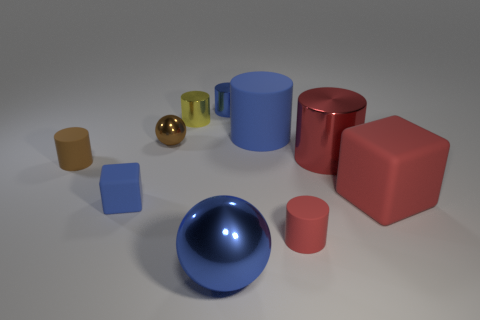There is a matte thing that is the same size as the red matte cube; what color is it?
Your answer should be compact. Blue. Do the blue metal thing that is behind the big matte cylinder and the tiny yellow thing have the same shape?
Offer a very short reply. Yes. There is a rubber cylinder that is to the left of the large blue matte cylinder right of the blue matte thing to the left of the blue metal sphere; what color is it?
Provide a succinct answer. Brown. Is there a red rubber block?
Your response must be concise. Yes. What number of other objects are the same size as the brown cylinder?
Provide a short and direct response. 5. There is a large matte cylinder; does it have the same color as the tiny object that is behind the yellow object?
Make the answer very short. Yes. What number of objects are blue metallic balls or big blocks?
Offer a terse response. 2. Do the tiny sphere and the small brown cylinder that is behind the small blue rubber cube have the same material?
Your response must be concise. No. The blue matte object that is behind the red metal object that is right of the small yellow thing is what shape?
Ensure brevity in your answer.  Cylinder. The tiny rubber thing that is in front of the big rubber block and to the left of the brown metallic sphere has what shape?
Your answer should be very brief. Cube. 